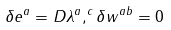<formula> <loc_0><loc_0><loc_500><loc_500>\delta e ^ { a } = D \lambda ^ { a } , ^ { c } \delta w ^ { a b } = 0</formula> 